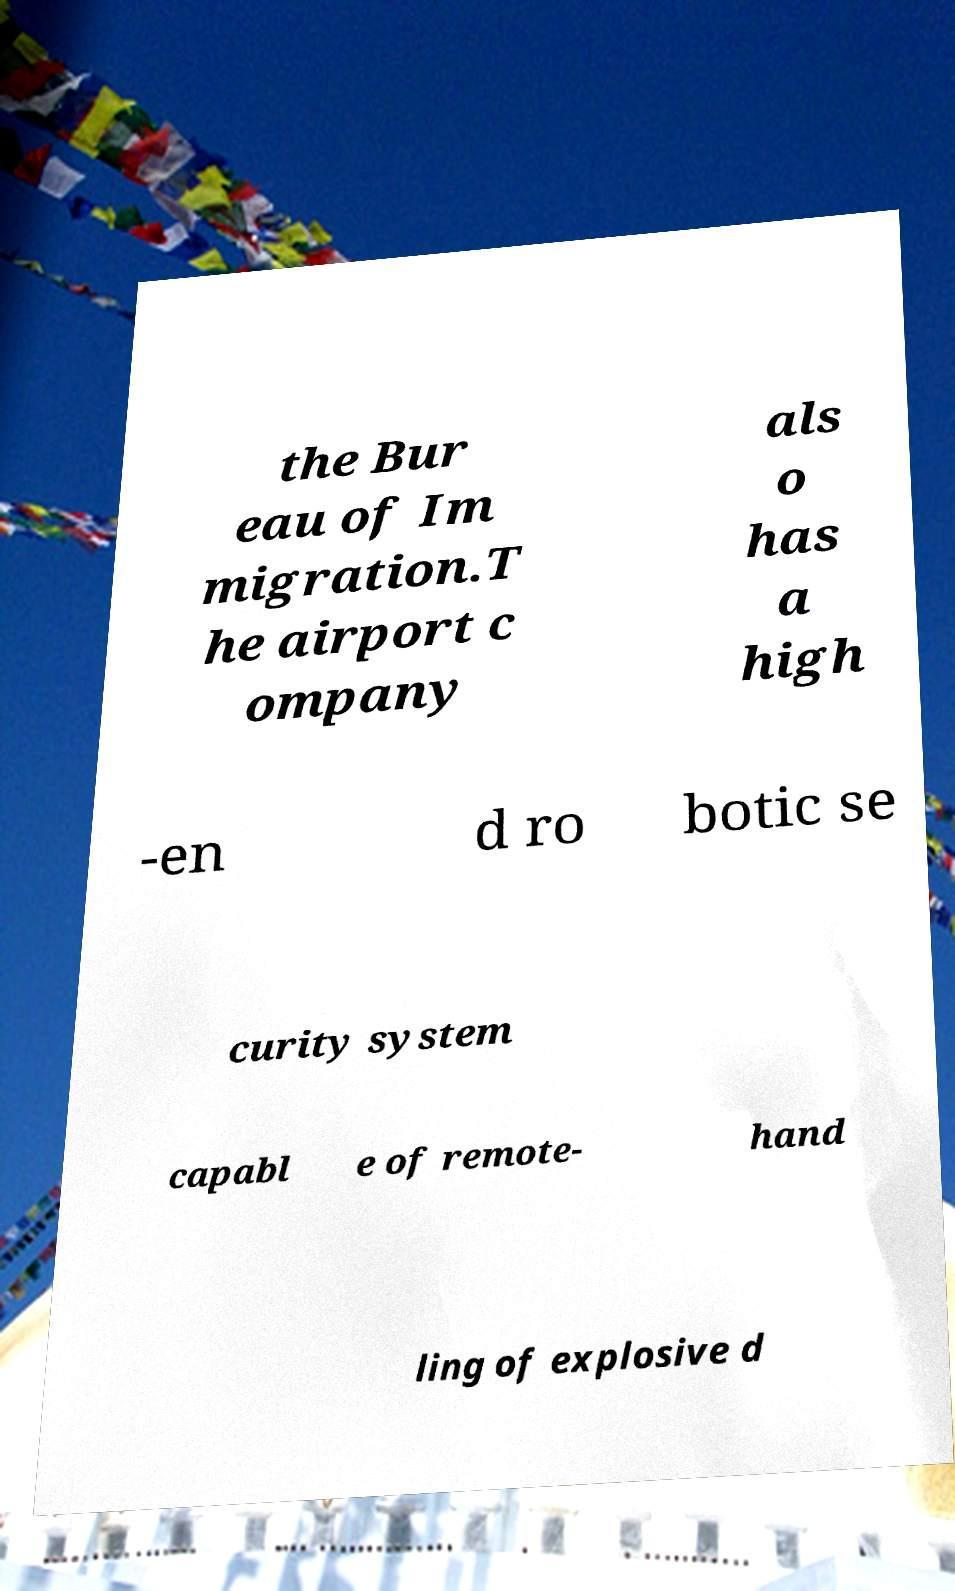Could you extract and type out the text from this image? the Bur eau of Im migration.T he airport c ompany als o has a high -en d ro botic se curity system capabl e of remote- hand ling of explosive d 